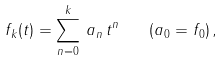<formula> <loc_0><loc_0><loc_500><loc_500>f _ { k } ( t ) = \sum _ { n = 0 } ^ { k } \, a _ { n } \, t ^ { n } \quad ( a _ { 0 } = f _ { 0 } ) \, ,</formula> 